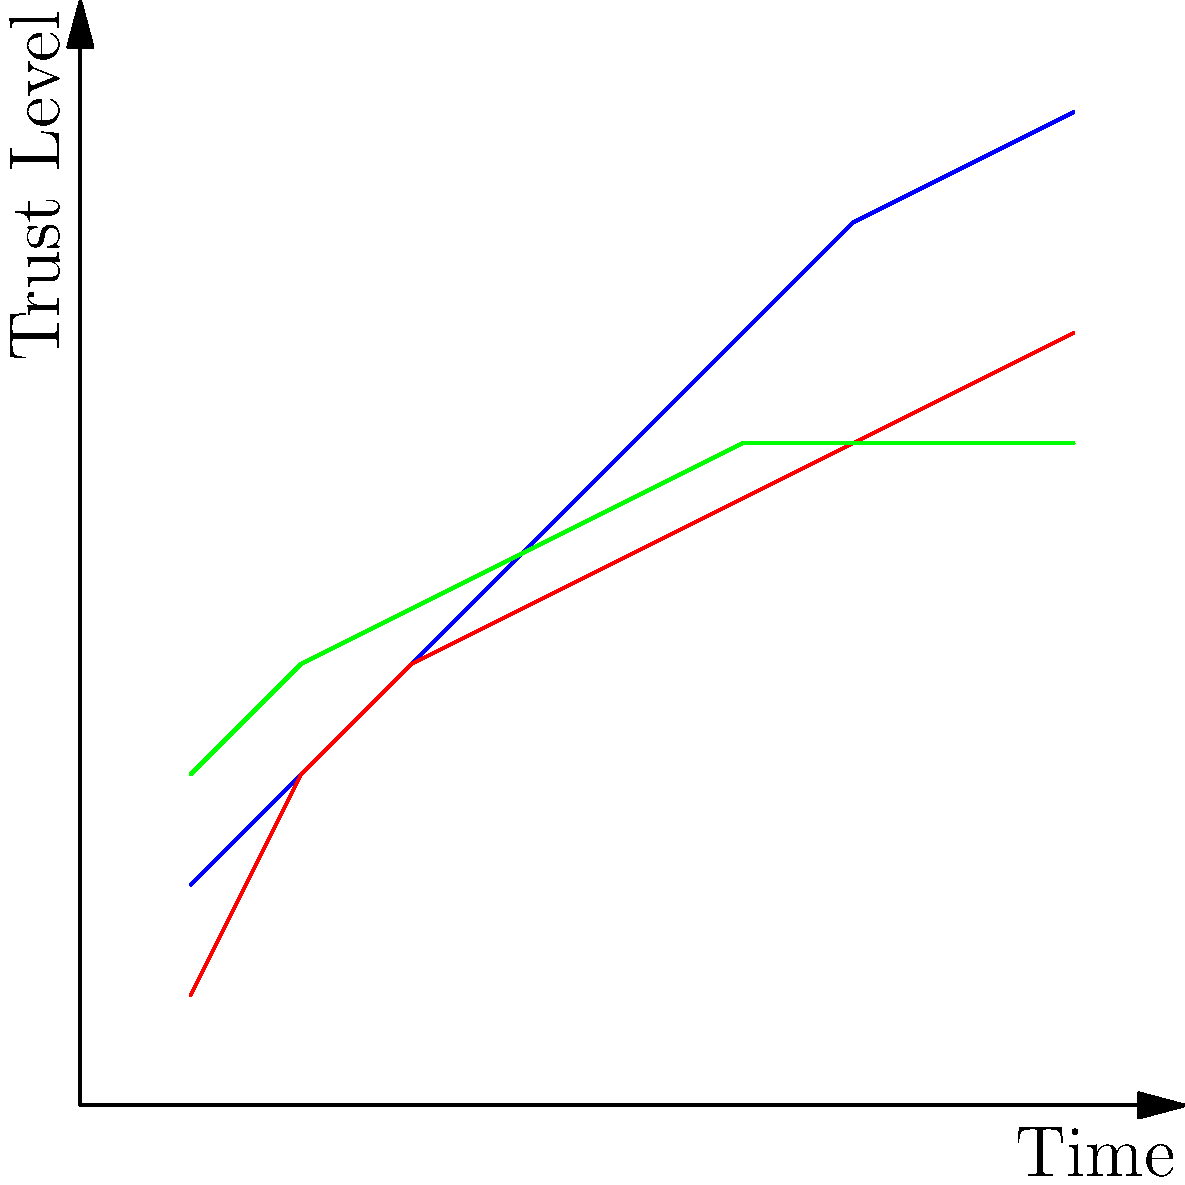Based on the graph showing trust levels over time for three potential business partners, which partner demonstrates the most consistent and reliable growth in trustworthiness, making them the ideal choice for a cautious entrepreneur? To determine the most consistent and reliable growth in trustworthiness, we need to analyze the trend for each partner:

1. Partner A (blue line):
   - Starts at a low trust level but shows rapid and consistent growth.
   - The slope is steeper, indicating faster trust-building.
   - Reaches the highest trust level by the end.

2. Partner B (red line):
   - Begins with the lowest trust level.
   - Shows steady growth but at a slower rate than Partner A.
   - Never reaches the same high levels as Partner A.

3. Partner C (green line):
   - Starts with the highest initial trust level.
   - Shows moderate growth initially.
   - Growth plateaus around the midpoint and remains constant.

For a cautious entrepreneur, consistency and reliability are key factors. While Partner A shows the most growth and reaches the highest trust level, the rapid increase might be seen as less stable or potentially risky.

Partner B shows steady growth but never reaches high levels of trust, which might not be ideal for long-term partnerships.

Partner C demonstrates the most consistent and reliable growth pattern. Although the growth is not as dramatic as Partner A, it shows:
   - A solid starting point (higher initial trust).
   - Steady growth in the early stages.
   - A stable plateau, indicating reliability and consistency over time.

This pattern suggests that Partner C has established a stable level of trustworthiness and maintains it, which aligns well with the needs of a cautious entrepreneur looking for reliability in a business partner.
Answer: Partner C 